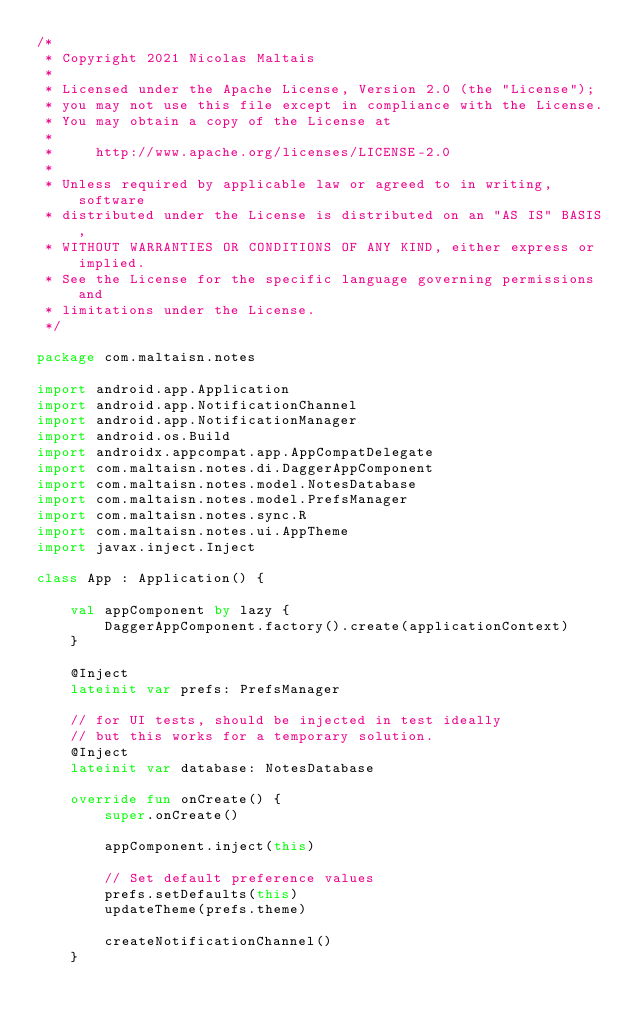Convert code to text. <code><loc_0><loc_0><loc_500><loc_500><_Kotlin_>/*
 * Copyright 2021 Nicolas Maltais
 *
 * Licensed under the Apache License, Version 2.0 (the "License");
 * you may not use this file except in compliance with the License.
 * You may obtain a copy of the License at
 *
 *     http://www.apache.org/licenses/LICENSE-2.0
 *
 * Unless required by applicable law or agreed to in writing, software
 * distributed under the License is distributed on an "AS IS" BASIS,
 * WITHOUT WARRANTIES OR CONDITIONS OF ANY KIND, either express or implied.
 * See the License for the specific language governing permissions and
 * limitations under the License.
 */

package com.maltaisn.notes

import android.app.Application
import android.app.NotificationChannel
import android.app.NotificationManager
import android.os.Build
import androidx.appcompat.app.AppCompatDelegate
import com.maltaisn.notes.di.DaggerAppComponent
import com.maltaisn.notes.model.NotesDatabase
import com.maltaisn.notes.model.PrefsManager
import com.maltaisn.notes.sync.R
import com.maltaisn.notes.ui.AppTheme
import javax.inject.Inject

class App : Application() {

    val appComponent by lazy {
        DaggerAppComponent.factory().create(applicationContext)
    }

    @Inject
    lateinit var prefs: PrefsManager

    // for UI tests, should be injected in test ideally
    // but this works for a temporary solution.
    @Inject
    lateinit var database: NotesDatabase

    override fun onCreate() {
        super.onCreate()

        appComponent.inject(this)

        // Set default preference values
        prefs.setDefaults(this)
        updateTheme(prefs.theme)

        createNotificationChannel()
    }
</code> 